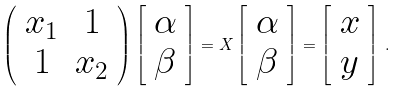Convert formula to latex. <formula><loc_0><loc_0><loc_500><loc_500>\left ( \begin{array} { c c } x _ { 1 } & 1 \\ 1 & x _ { 2 } \end{array} \right ) \left [ \begin{array} { c } \alpha \\ \beta \end{array} \right ] = X \left [ \begin{array} { c } \alpha \\ \beta \end{array} \right ] = \left [ \begin{array} { c } x \\ y \end{array} \right ] \, .</formula> 